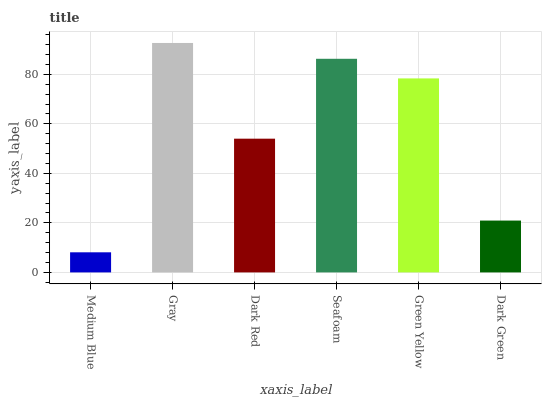Is Medium Blue the minimum?
Answer yes or no. Yes. Is Gray the maximum?
Answer yes or no. Yes. Is Dark Red the minimum?
Answer yes or no. No. Is Dark Red the maximum?
Answer yes or no. No. Is Gray greater than Dark Red?
Answer yes or no. Yes. Is Dark Red less than Gray?
Answer yes or no. Yes. Is Dark Red greater than Gray?
Answer yes or no. No. Is Gray less than Dark Red?
Answer yes or no. No. Is Green Yellow the high median?
Answer yes or no. Yes. Is Dark Red the low median?
Answer yes or no. Yes. Is Medium Blue the high median?
Answer yes or no. No. Is Dark Green the low median?
Answer yes or no. No. 